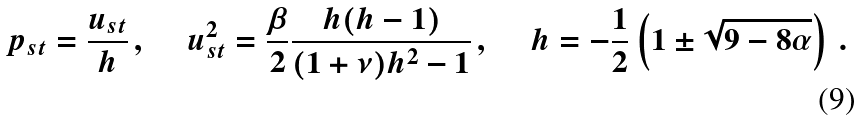Convert formula to latex. <formula><loc_0><loc_0><loc_500><loc_500>p _ { s t } = \frac { u _ { s t } } { h } \, , \quad \ u _ { s t } ^ { 2 } = \frac { \beta } { 2 } \frac { h ( h - 1 ) } { ( 1 + \nu ) h ^ { 2 } - 1 } \, , \quad \ h = - \frac { 1 } { 2 } \left ( 1 \pm \sqrt { 9 - 8 \alpha } \right ) \, .</formula> 